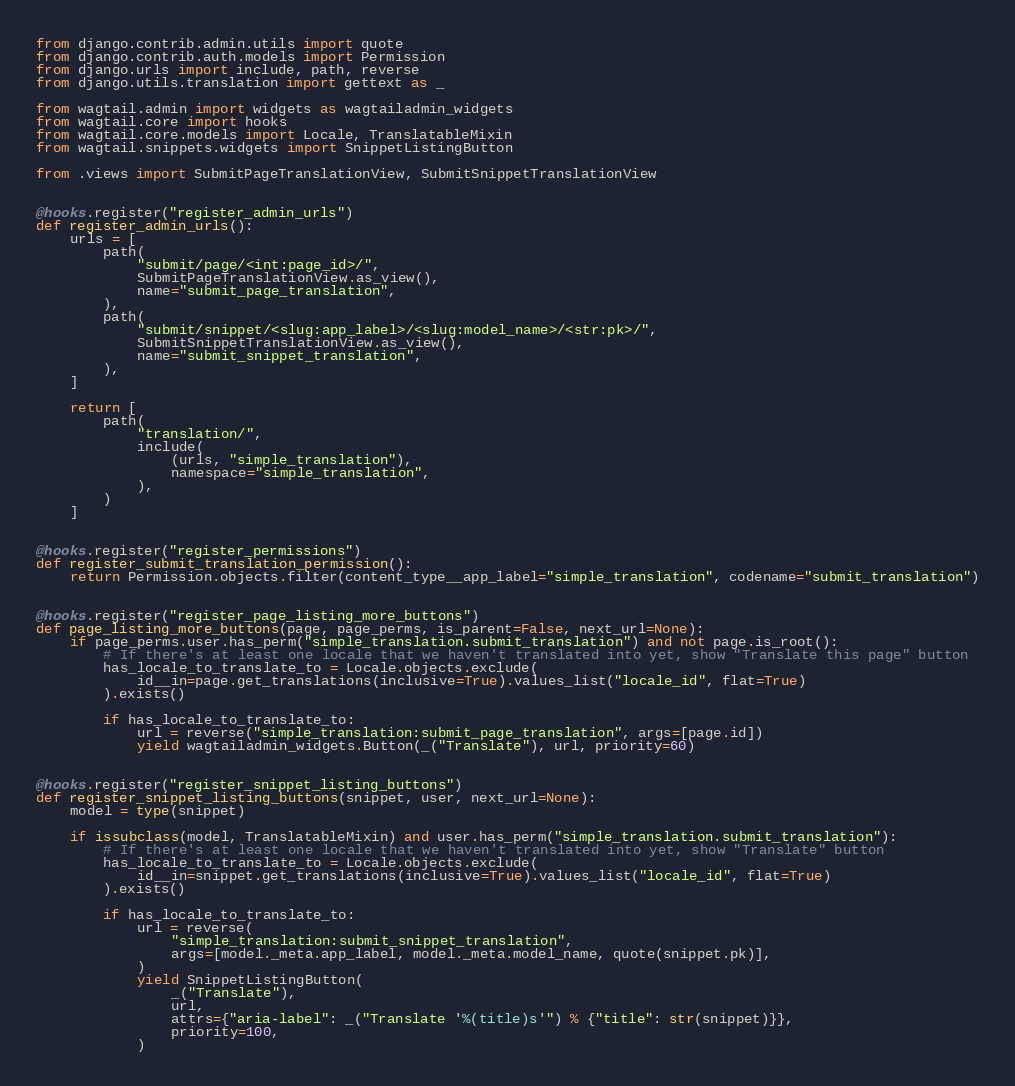<code> <loc_0><loc_0><loc_500><loc_500><_Python_>from django.contrib.admin.utils import quote
from django.contrib.auth.models import Permission
from django.urls import include, path, reverse
from django.utils.translation import gettext as _

from wagtail.admin import widgets as wagtailadmin_widgets
from wagtail.core import hooks
from wagtail.core.models import Locale, TranslatableMixin
from wagtail.snippets.widgets import SnippetListingButton

from .views import SubmitPageTranslationView, SubmitSnippetTranslationView


@hooks.register("register_admin_urls")
def register_admin_urls():
    urls = [
        path(
            "submit/page/<int:page_id>/",
            SubmitPageTranslationView.as_view(),
            name="submit_page_translation",
        ),
        path(
            "submit/snippet/<slug:app_label>/<slug:model_name>/<str:pk>/",
            SubmitSnippetTranslationView.as_view(),
            name="submit_snippet_translation",
        ),
    ]

    return [
        path(
            "translation/",
            include(
                (urls, "simple_translation"),
                namespace="simple_translation",
            ),
        )
    ]


@hooks.register("register_permissions")
def register_submit_translation_permission():
    return Permission.objects.filter(content_type__app_label="simple_translation", codename="submit_translation")


@hooks.register("register_page_listing_more_buttons")
def page_listing_more_buttons(page, page_perms, is_parent=False, next_url=None):
    if page_perms.user.has_perm("simple_translation.submit_translation") and not page.is_root():
        # If there's at least one locale that we haven't translated into yet, show "Translate this page" button
        has_locale_to_translate_to = Locale.objects.exclude(
            id__in=page.get_translations(inclusive=True).values_list("locale_id", flat=True)
        ).exists()

        if has_locale_to_translate_to:
            url = reverse("simple_translation:submit_page_translation", args=[page.id])
            yield wagtailadmin_widgets.Button(_("Translate"), url, priority=60)


@hooks.register("register_snippet_listing_buttons")
def register_snippet_listing_buttons(snippet, user, next_url=None):
    model = type(snippet)

    if issubclass(model, TranslatableMixin) and user.has_perm("simple_translation.submit_translation"):
        # If there's at least one locale that we haven't translated into yet, show "Translate" button
        has_locale_to_translate_to = Locale.objects.exclude(
            id__in=snippet.get_translations(inclusive=True).values_list("locale_id", flat=True)
        ).exists()

        if has_locale_to_translate_to:
            url = reverse(
                "simple_translation:submit_snippet_translation",
                args=[model._meta.app_label, model._meta.model_name, quote(snippet.pk)],
            )
            yield SnippetListingButton(
                _("Translate"),
                url,
                attrs={"aria-label": _("Translate '%(title)s'") % {"title": str(snippet)}},
                priority=100,
            )
</code> 